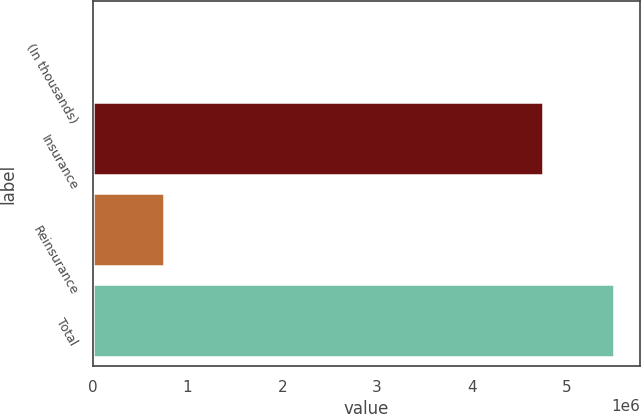Convert chart to OTSL. <chart><loc_0><loc_0><loc_500><loc_500><bar_chart><fcel>(In thousands)<fcel>Insurance<fcel>Reinsurance<fcel>Total<nl><fcel>2013<fcel>4.75057e+06<fcel>749601<fcel>5.50017e+06<nl></chart> 